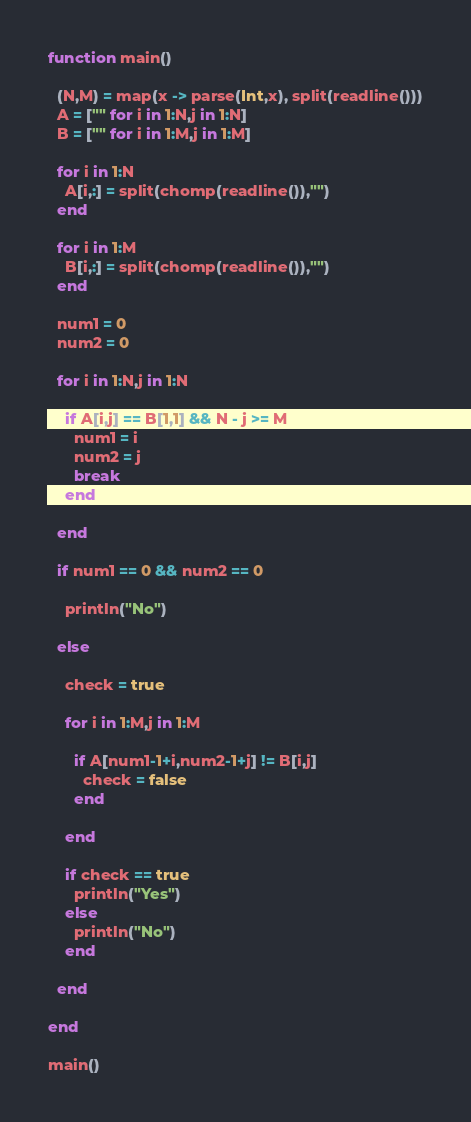Convert code to text. <code><loc_0><loc_0><loc_500><loc_500><_Julia_>function main()
  
  (N,M) = map(x -> parse(Int,x), split(readline()))
  A = ["" for i in 1:N,j in 1:N]
  B = ["" for i in 1:M,j in 1:M]
  
  for i in 1:N
    A[i,:] = split(chomp(readline()),"")
  end
  
  for i in 1:M
    B[i,:] = split(chomp(readline()),"")
  end
  
  num1 = 0
  num2 = 0
  
  for i in 1:N,j in 1:N
    
    if A[i,j] == B[1,1] && N - j >= M
      num1 = i
  	  num2 = j
      break
    end
    
  end

  if num1 == 0 && num2 == 0
    
    println("No")
  
  else
      
    check = true
  
    for i in 1:M,j in 1:M
    
      if A[num1-1+i,num2-1+j] != B[i,j]
        check = false
      end
    
    end
    
    if check == true
      println("Yes")
    else
      println("No")
    end
    
  end
  
end

main()</code> 